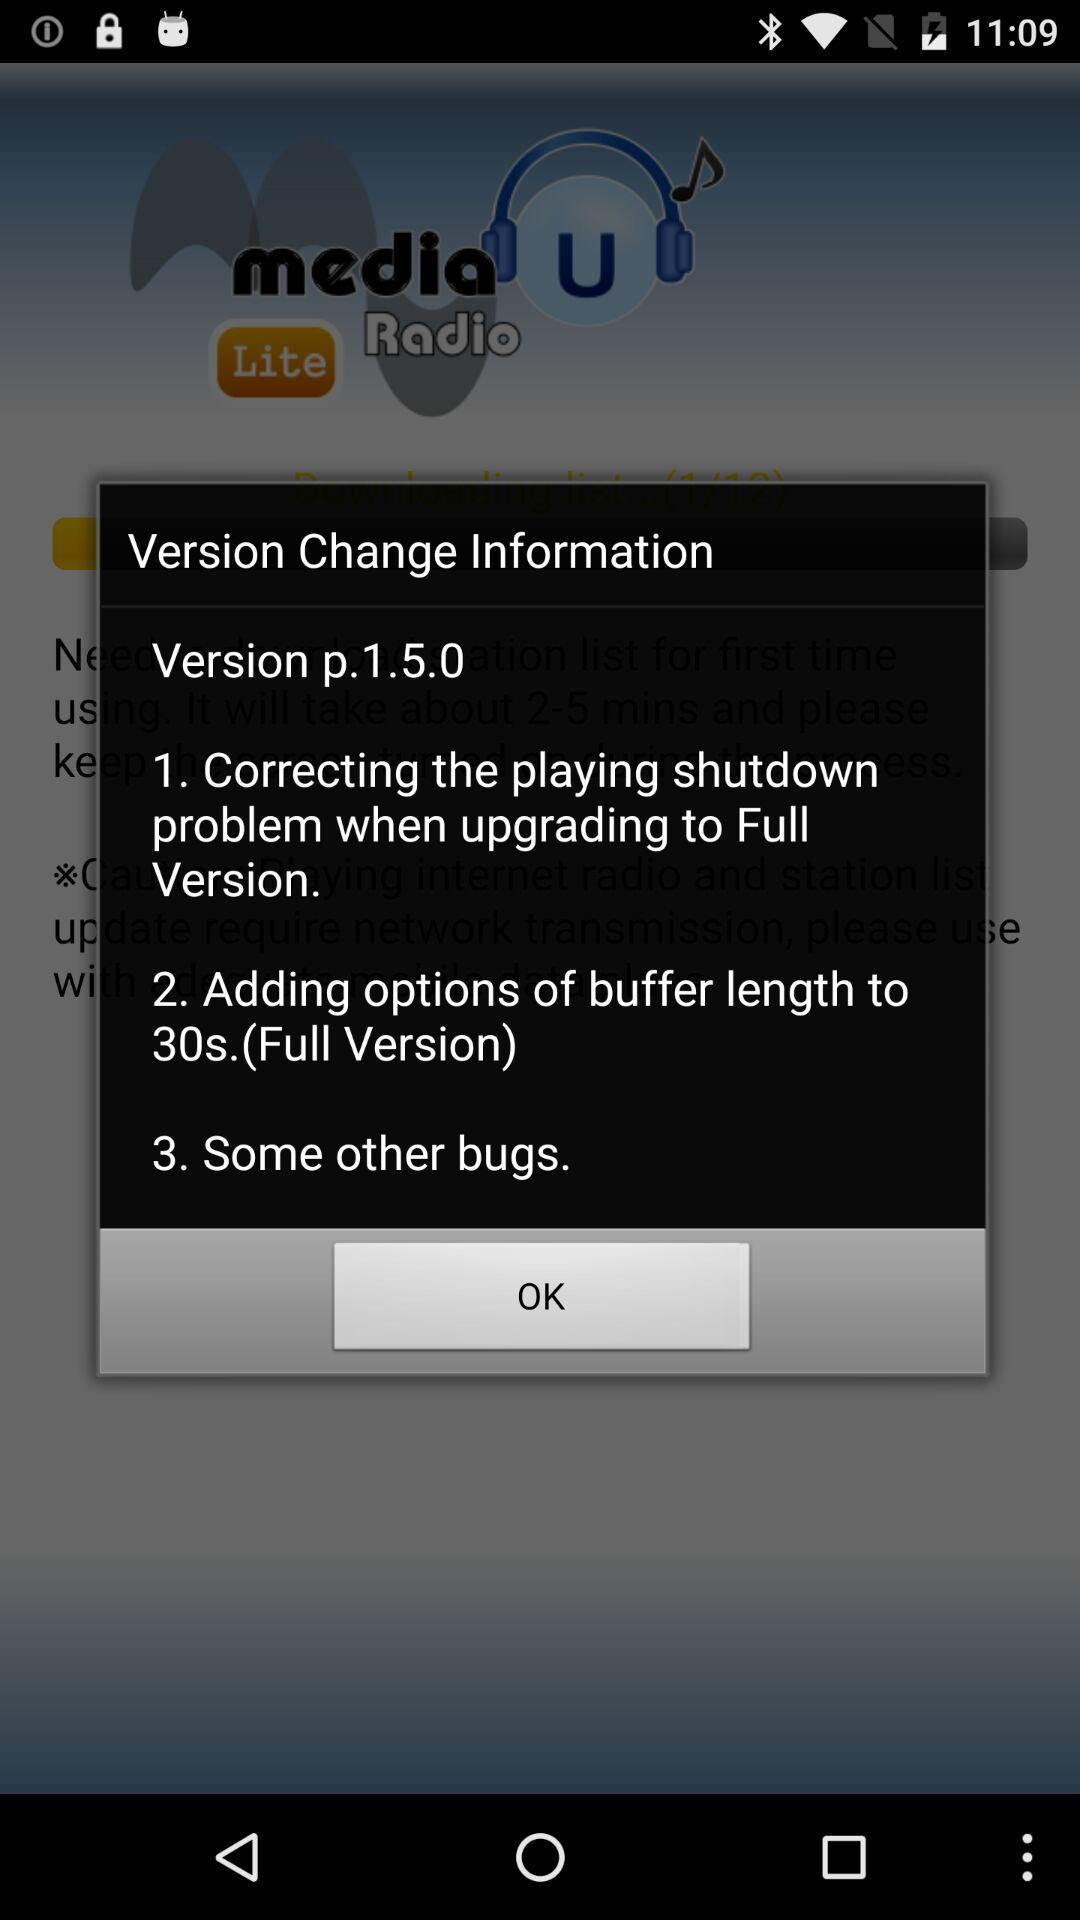Which version is used? The used version is p.1.5.0. 